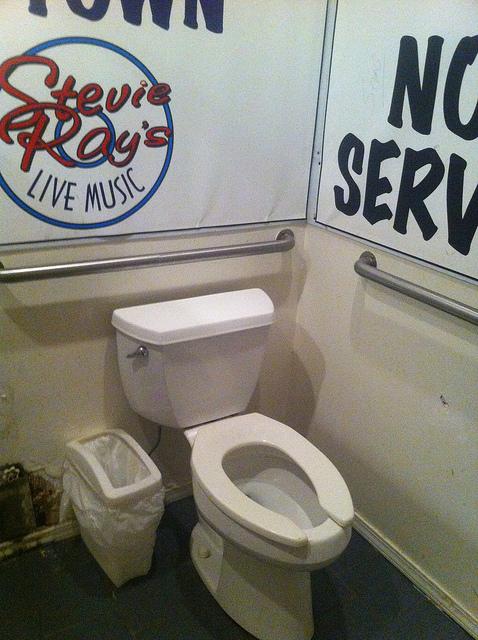Where is the trashcan?
Give a very brief answer. Next to toilet. Are there any posters in this toilet?
Quick response, please. Yes. Is there garbage laying around the base of the toilet?
Be succinct. No. 